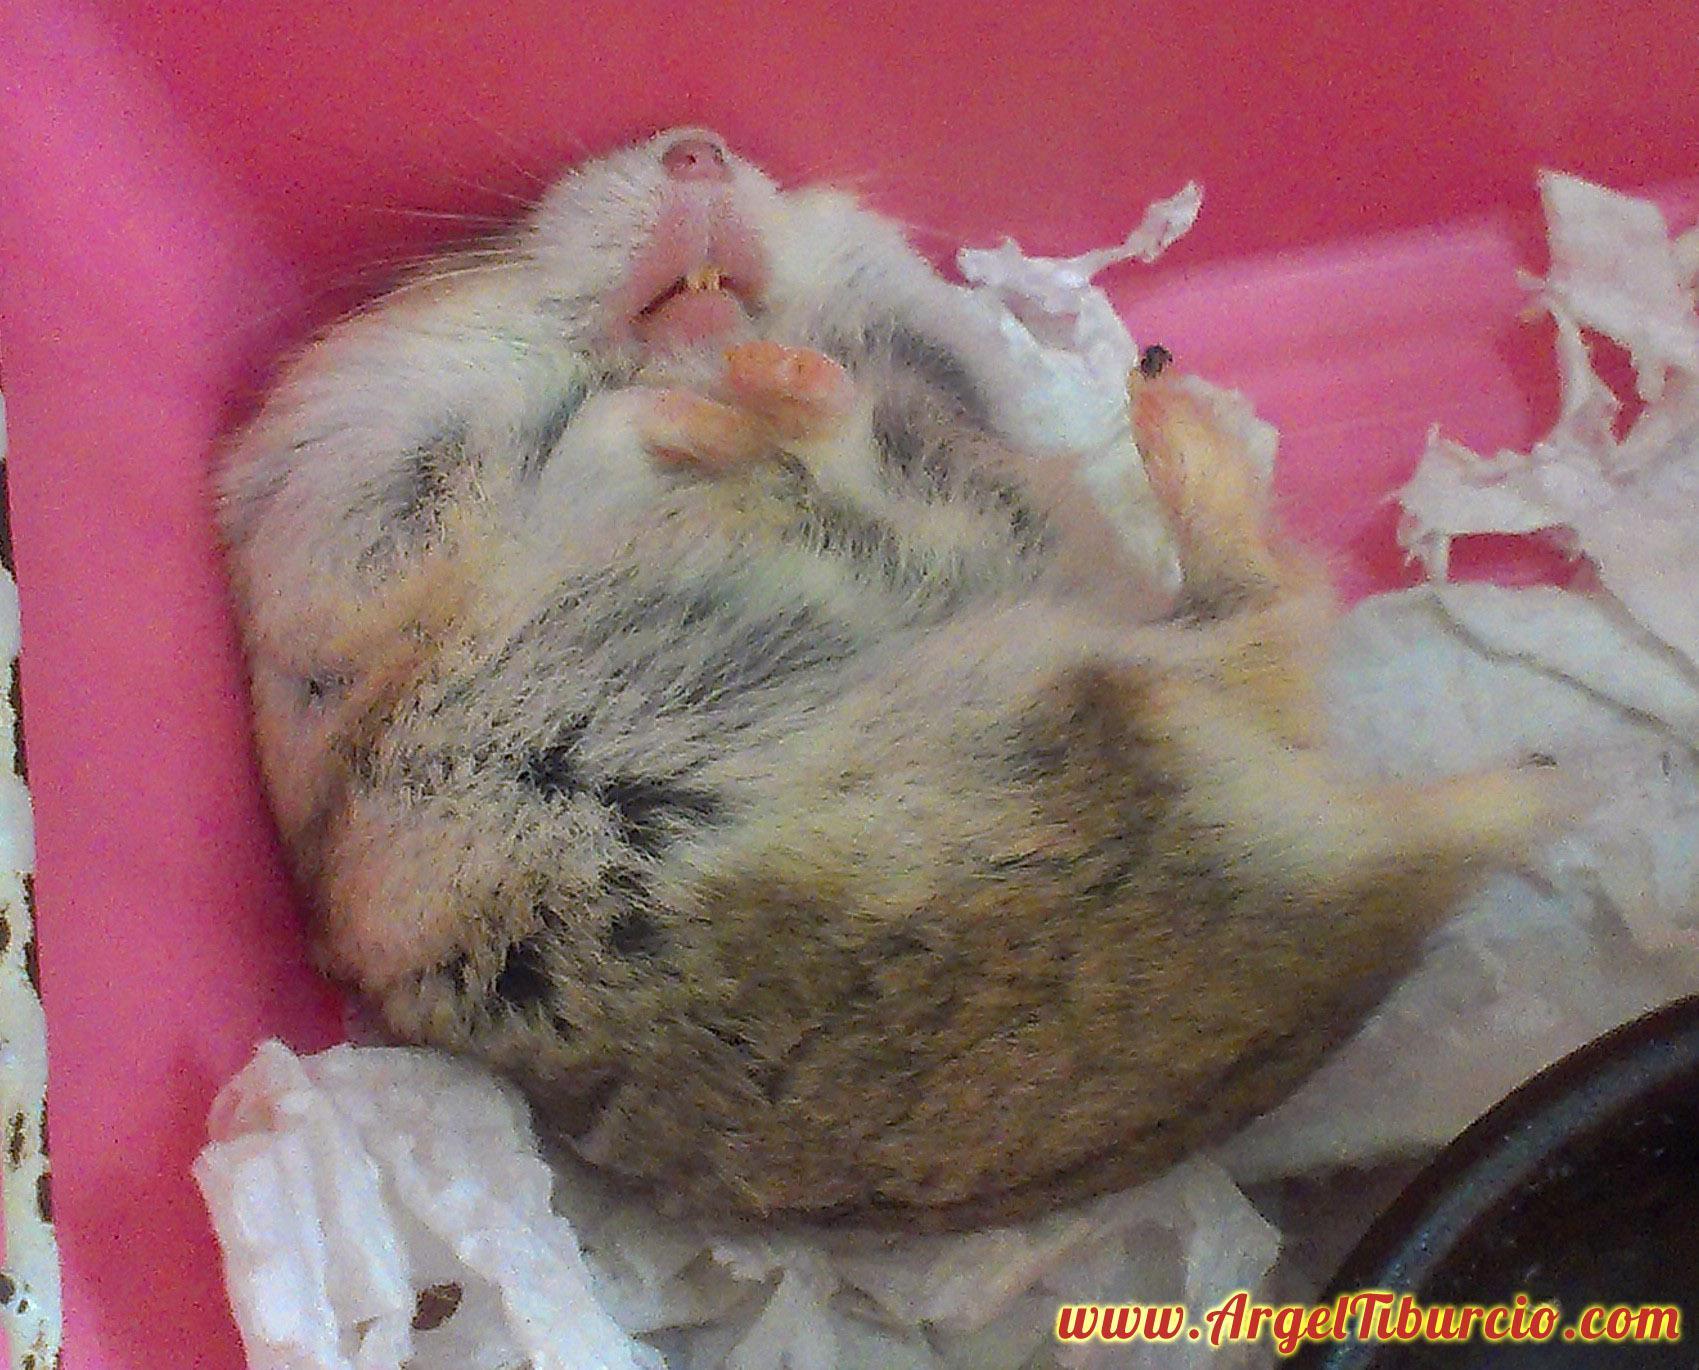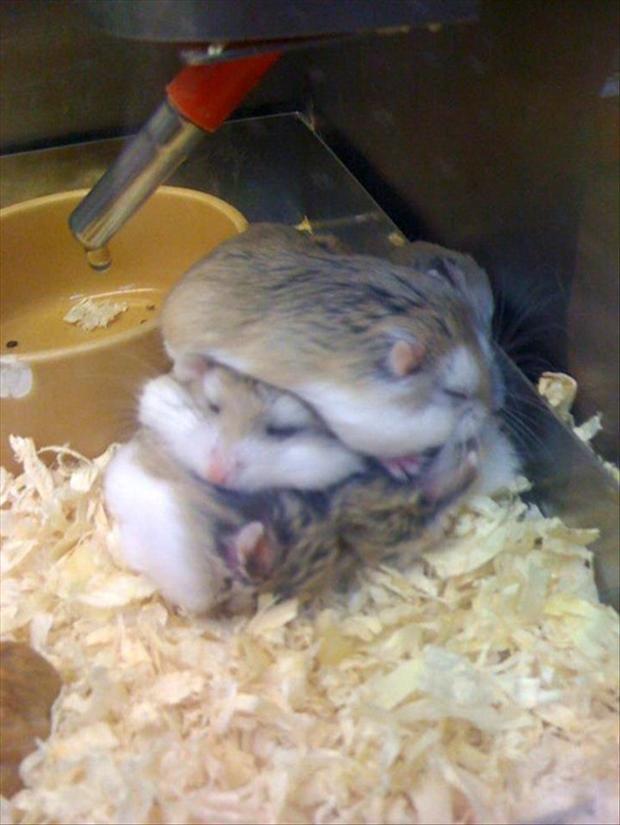The first image is the image on the left, the second image is the image on the right. Assess this claim about the two images: "The right image contains at least two hamsters.". Correct or not? Answer yes or no. Yes. The first image is the image on the left, the second image is the image on the right. For the images displayed, is the sentence "One image shows side-by-side hamsters, and the other shows one small pet in an upturned palm." factually correct? Answer yes or no. No. 